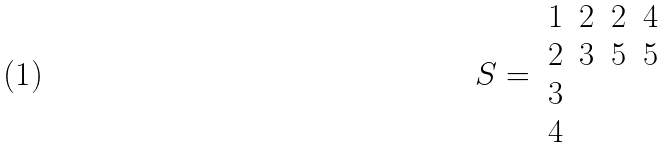<formula> <loc_0><loc_0><loc_500><loc_500>S = \begin{array} { c c c c } 1 & 2 & 2 & 4 \\ 2 & 3 & 5 & 5 \\ 3 & & & \\ 4 \end{array}</formula> 